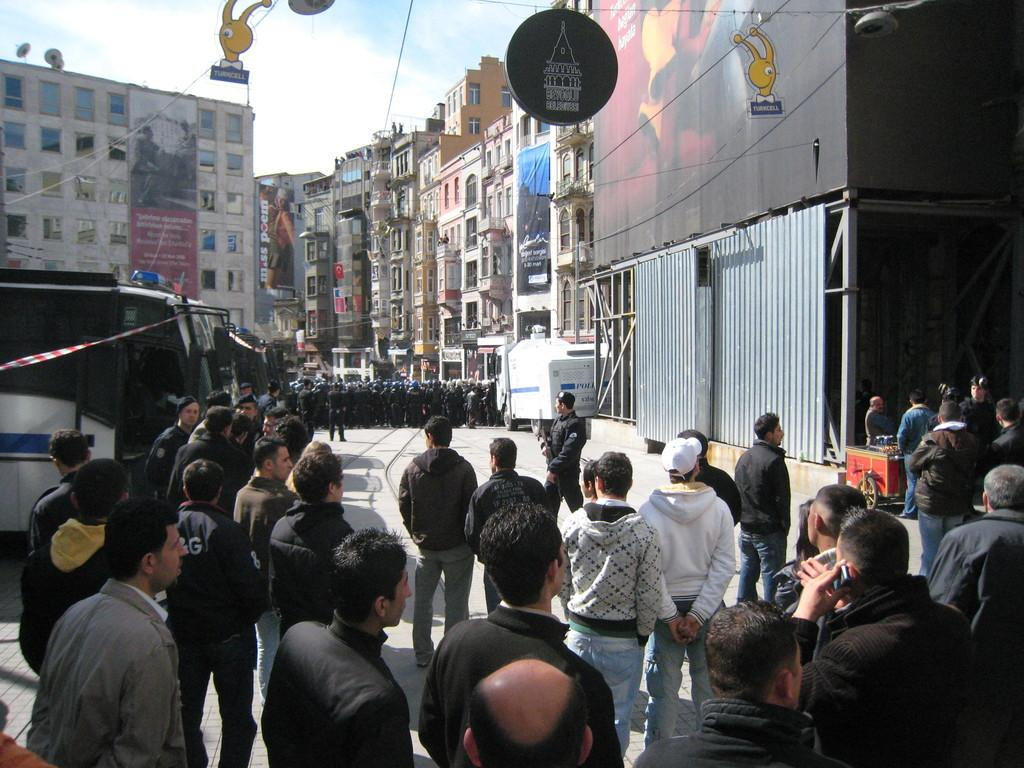What can be seen in the image involving people? There are people standing in the image. What else is present in the image besides people? There are vehicles, a shutter, a hoarding, wires, and buildings in the image. Where is the lake located in the image? There is no lake present in the image. What type of board is being used by the people in the image? There is no board visible in the image. 